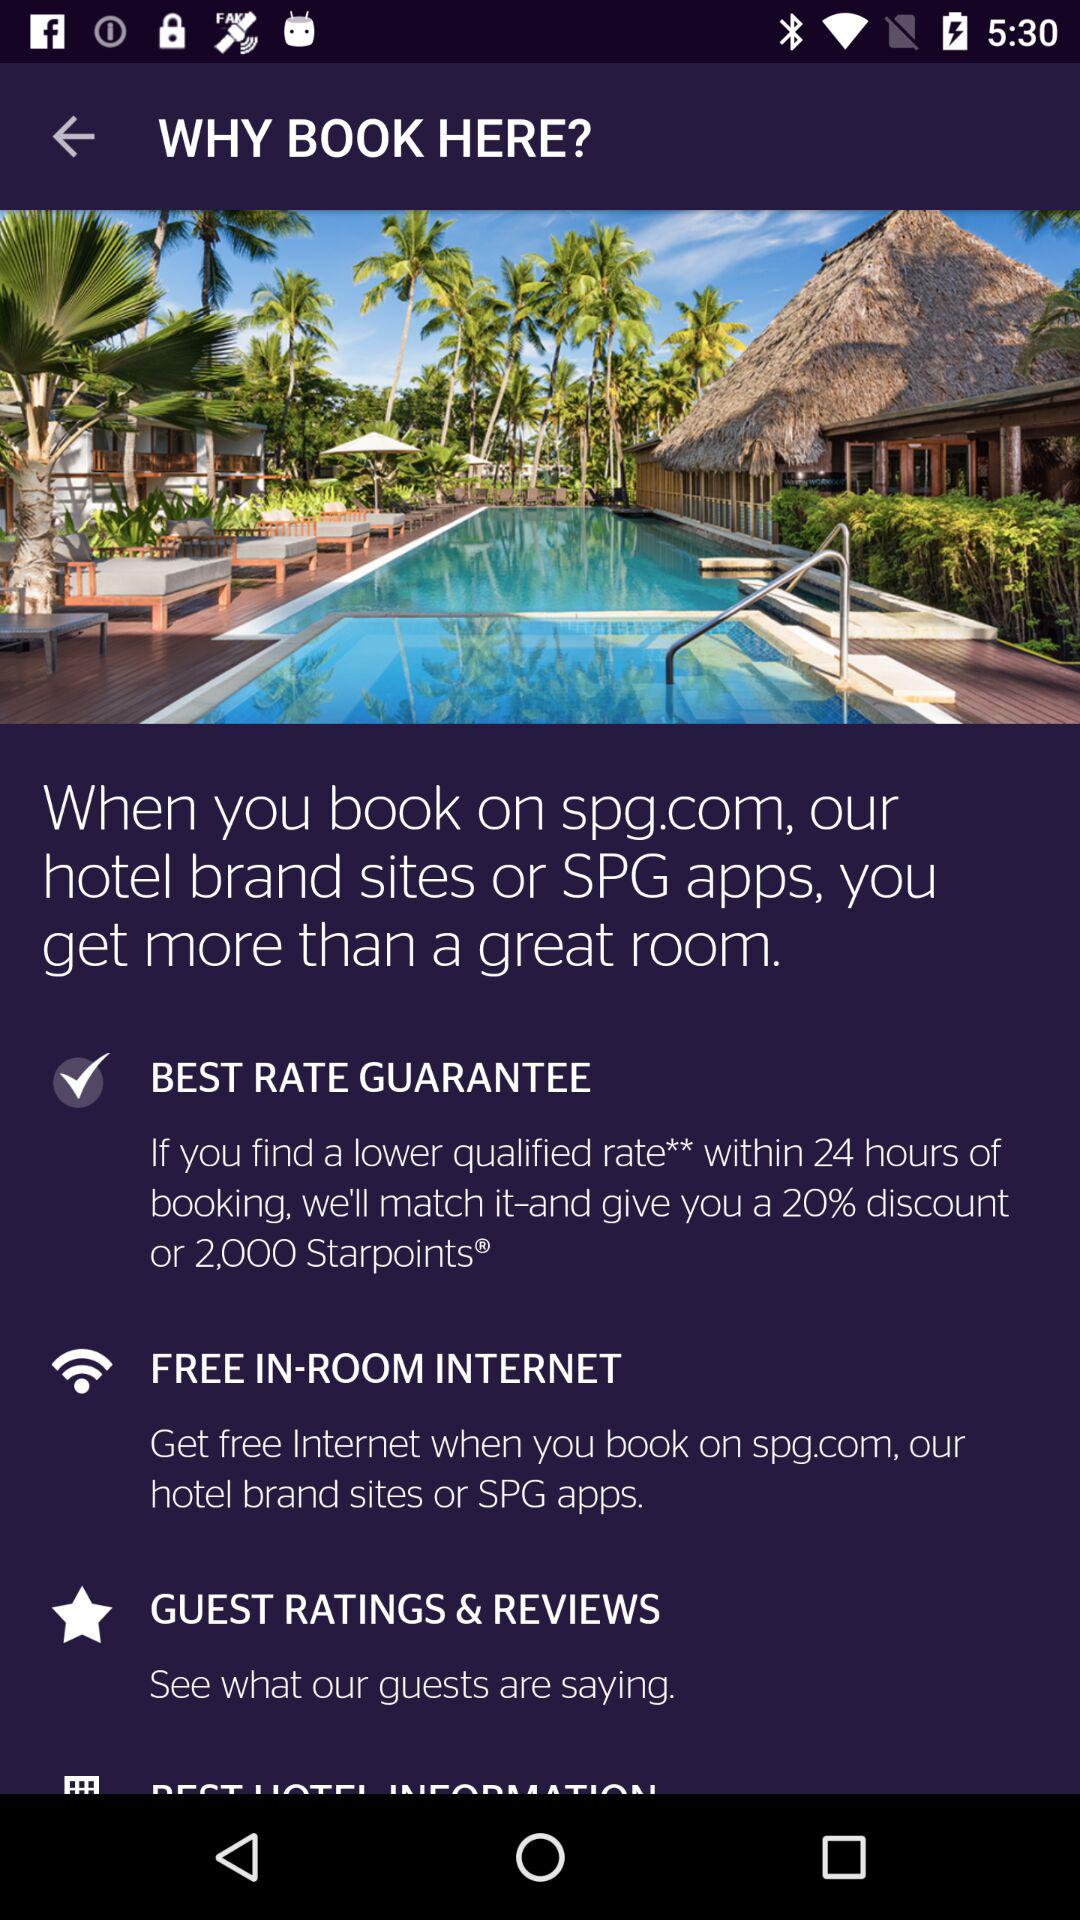What is the internet status?
When the provided information is insufficient, respond with <no answer>. <no answer> 